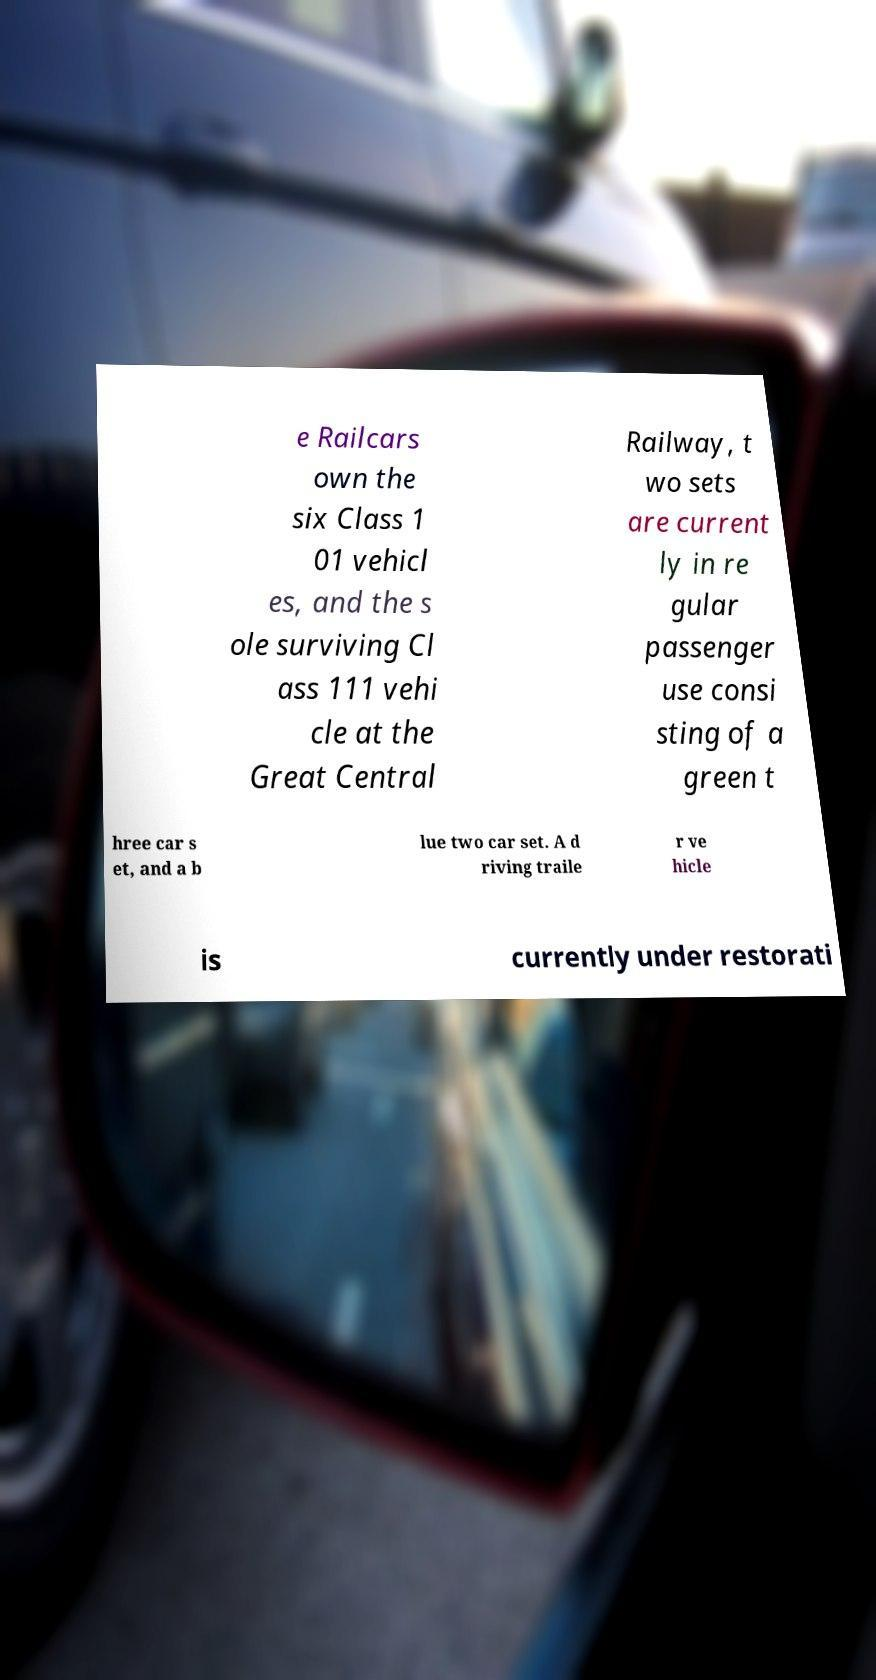For documentation purposes, I need the text within this image transcribed. Could you provide that? e Railcars own the six Class 1 01 vehicl es, and the s ole surviving Cl ass 111 vehi cle at the Great Central Railway, t wo sets are current ly in re gular passenger use consi sting of a green t hree car s et, and a b lue two car set. A d riving traile r ve hicle is currently under restorati 